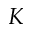<formula> <loc_0><loc_0><loc_500><loc_500>K</formula> 